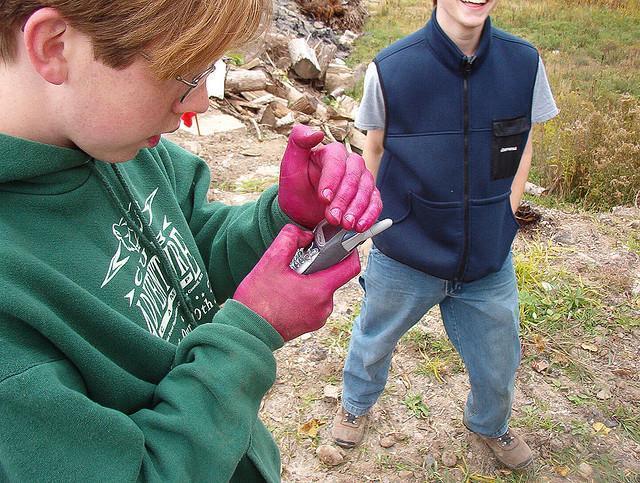How many people can be seen?
Give a very brief answer. 2. 